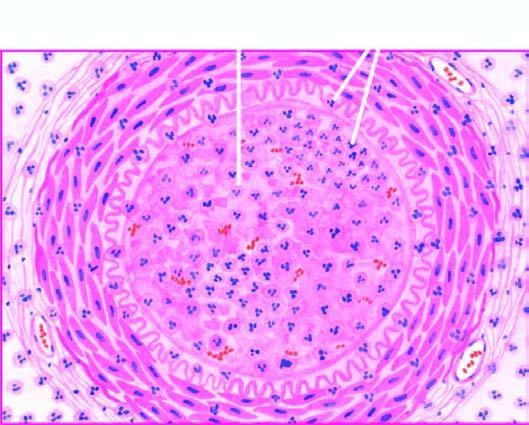s bone marrow in itp occluded by a thrombus containing microabscesses?
Answer the question using a single word or phrase. No 